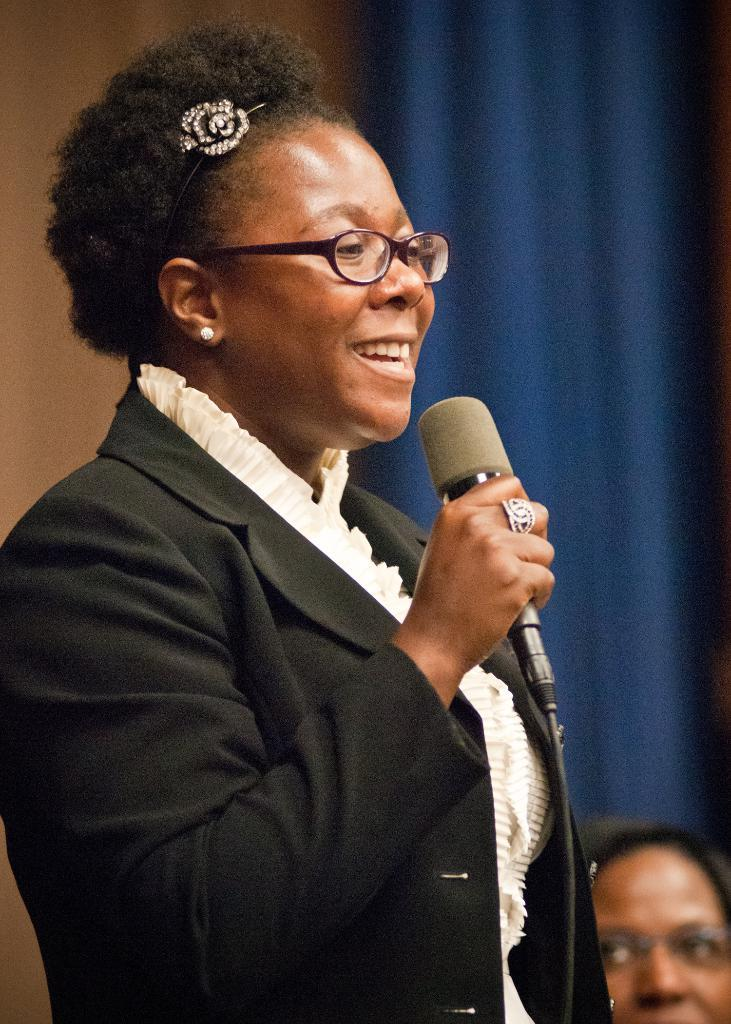What is the woman in the image wearing? The woman is wearing a blazer. What accessory is the woman wearing in the image? The woman is wearing spectacles. What is the woman holding in her hand in the image? The woman is holding a mic in her hand. What is the woman's facial expression in the image? The woman is smiling. Can you describe the background of the image? There is a person, a wall, and a curtain in the background of the image. What type of muscle can be seen flexing in the image? There is no muscle visible in the image; it features a woman holding a mic and wearing a blazer and spectacles. 